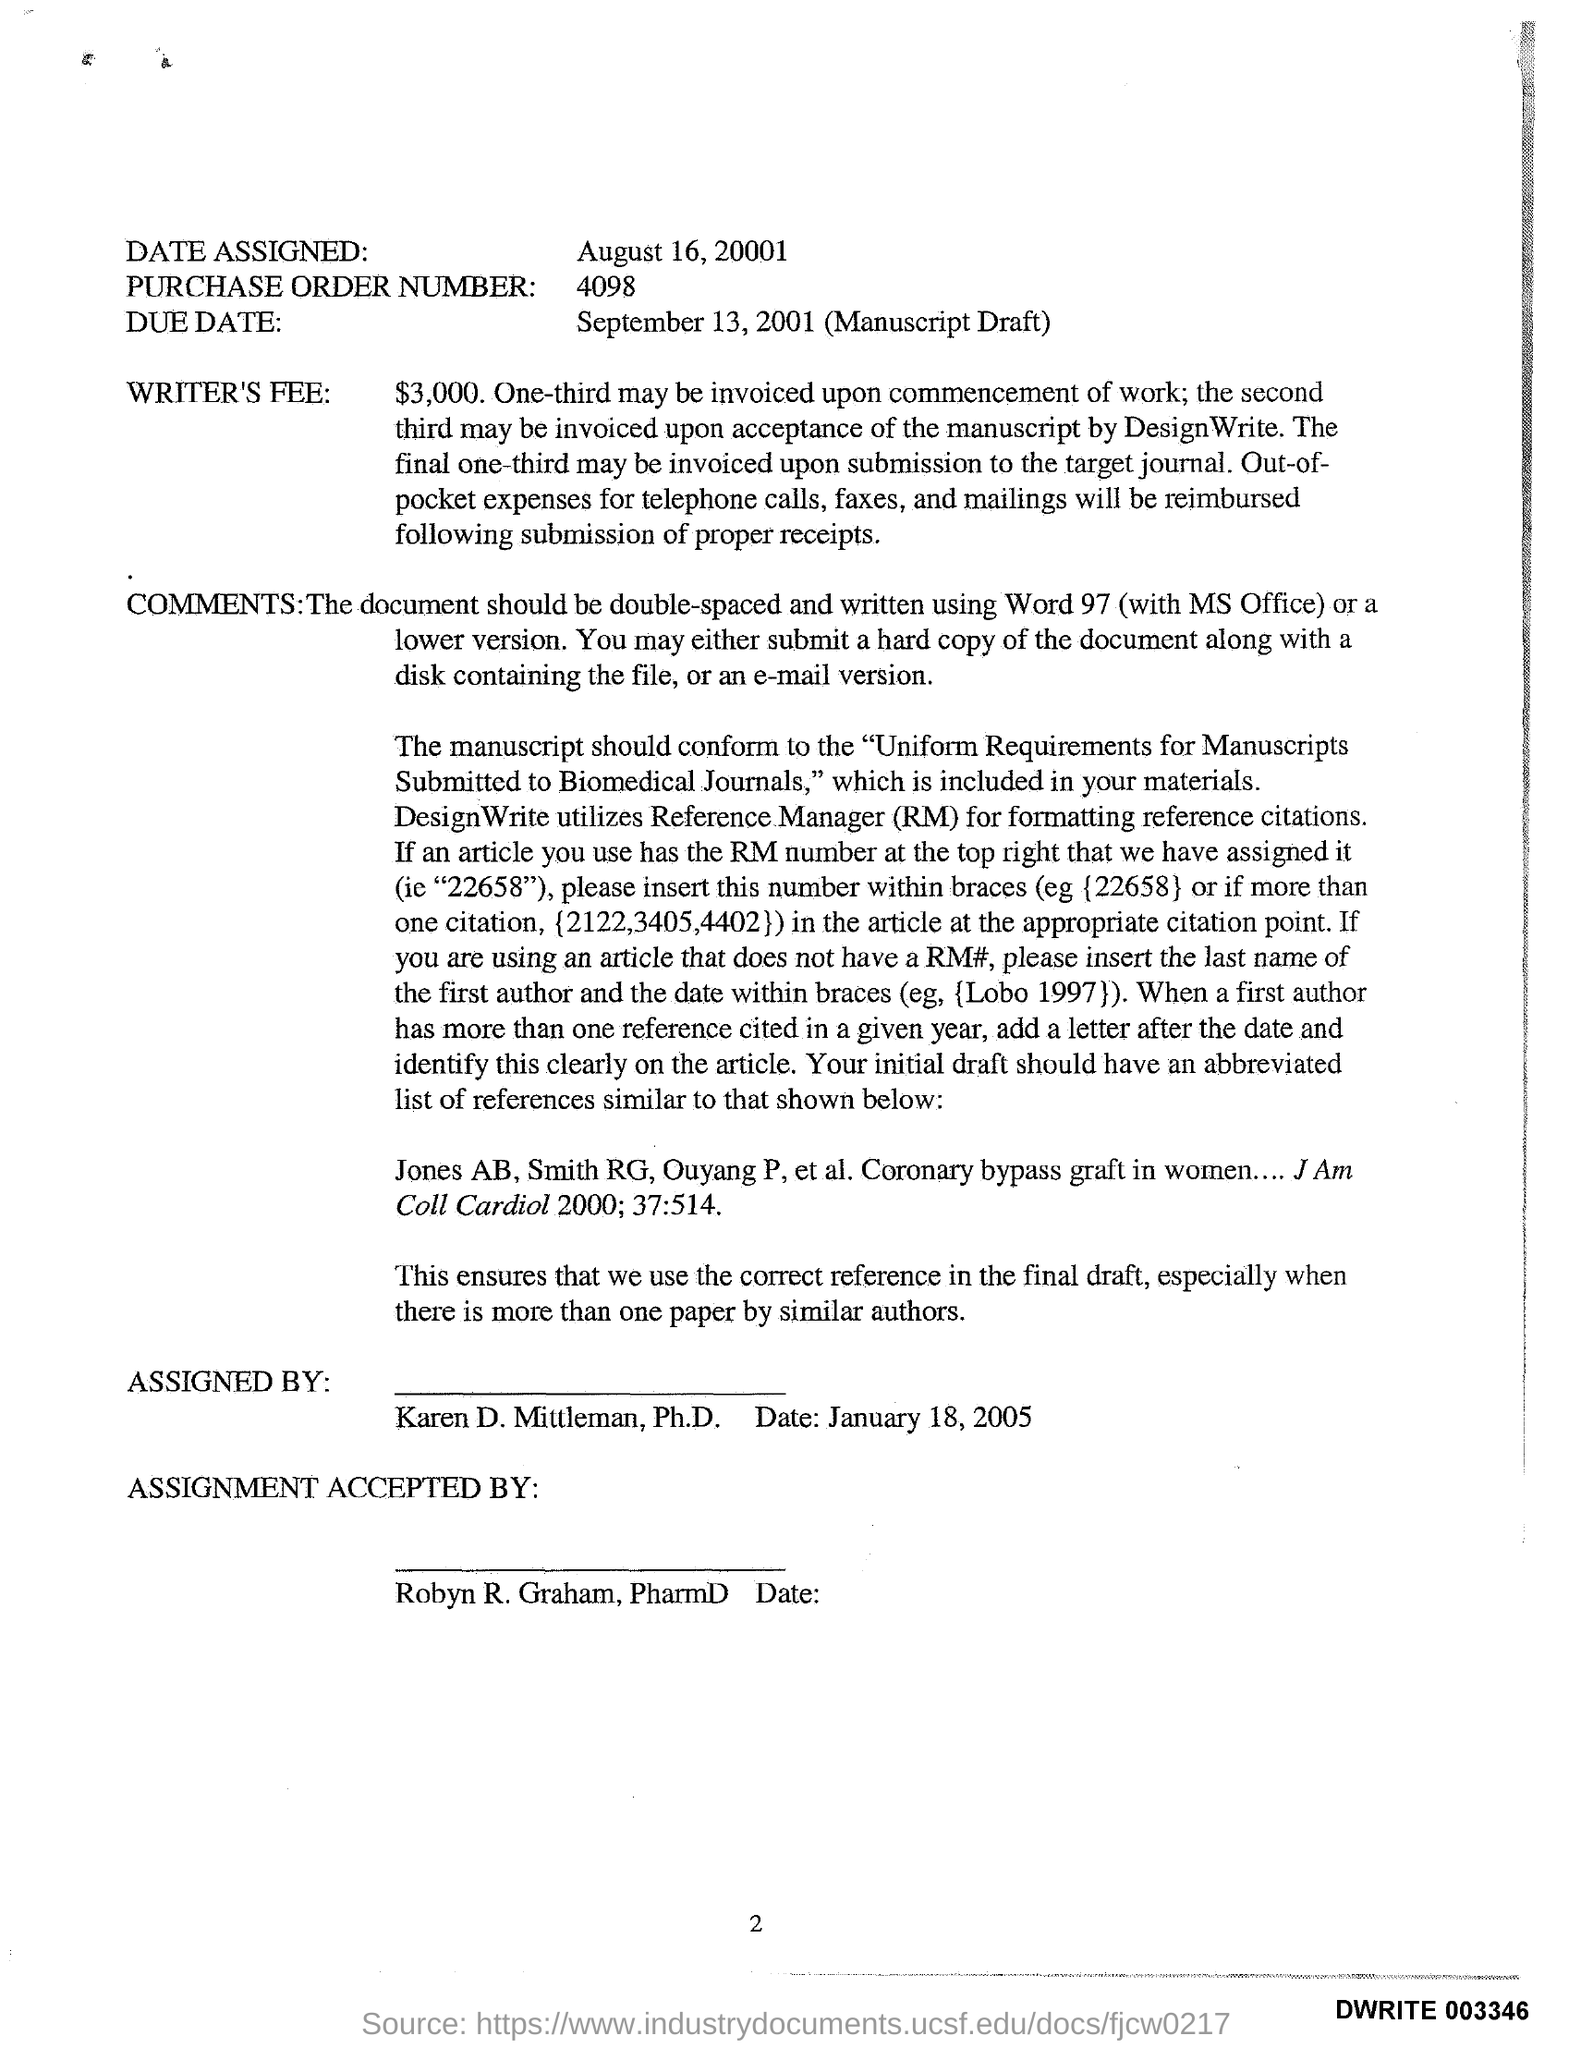What is the date assigned ?
Your response must be concise. August 16, 20001. What is the purchase order number ?
Ensure brevity in your answer.  4098. What is the due date ?
Provide a succinct answer. September 13, 2001. What is the wtiter's fee ?
Offer a terse response. $3000. Who accepted the assingnment ?
Give a very brief answer. Robyn r. graham, pharmd. 